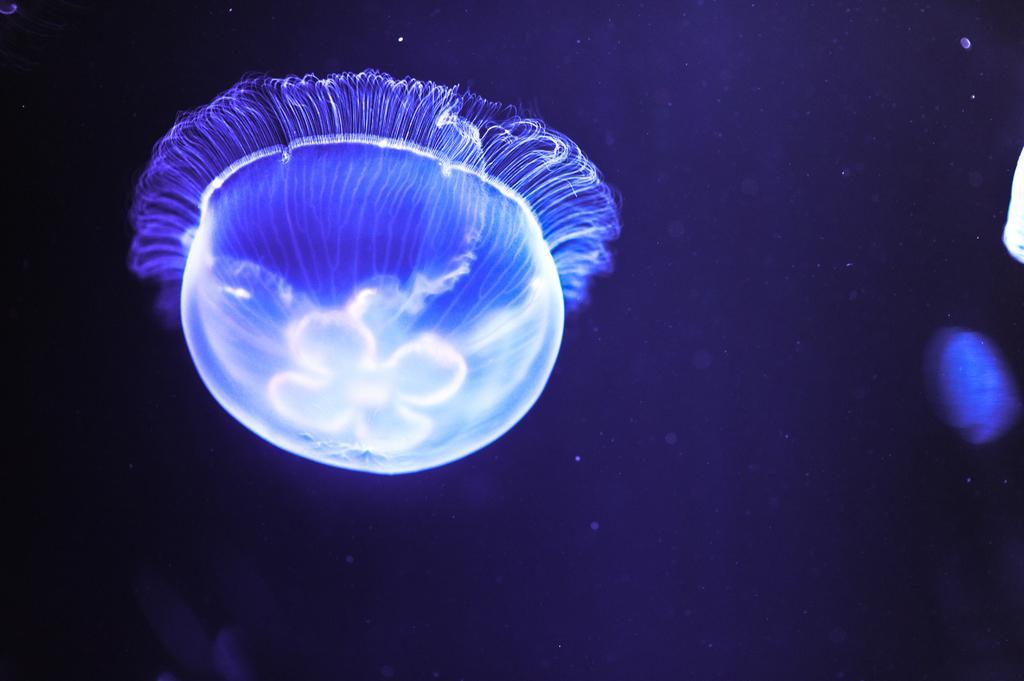Describe this image in one or two sentences. In this image we can see a blue colored jellyfish. 